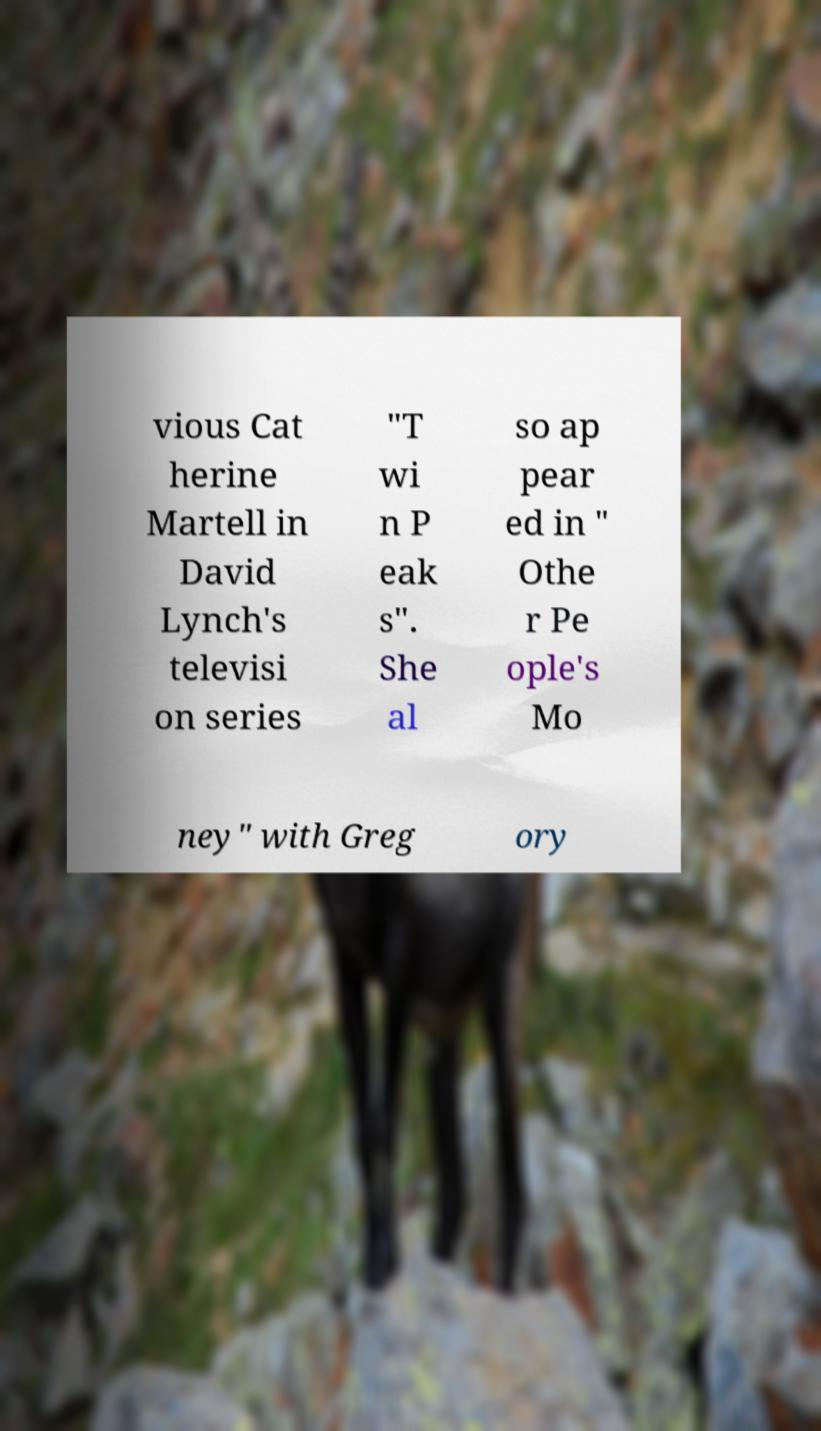For documentation purposes, I need the text within this image transcribed. Could you provide that? vious Cat herine Martell in David Lynch's televisi on series "T wi n P eak s". She al so ap pear ed in " Othe r Pe ople's Mo ney" with Greg ory 